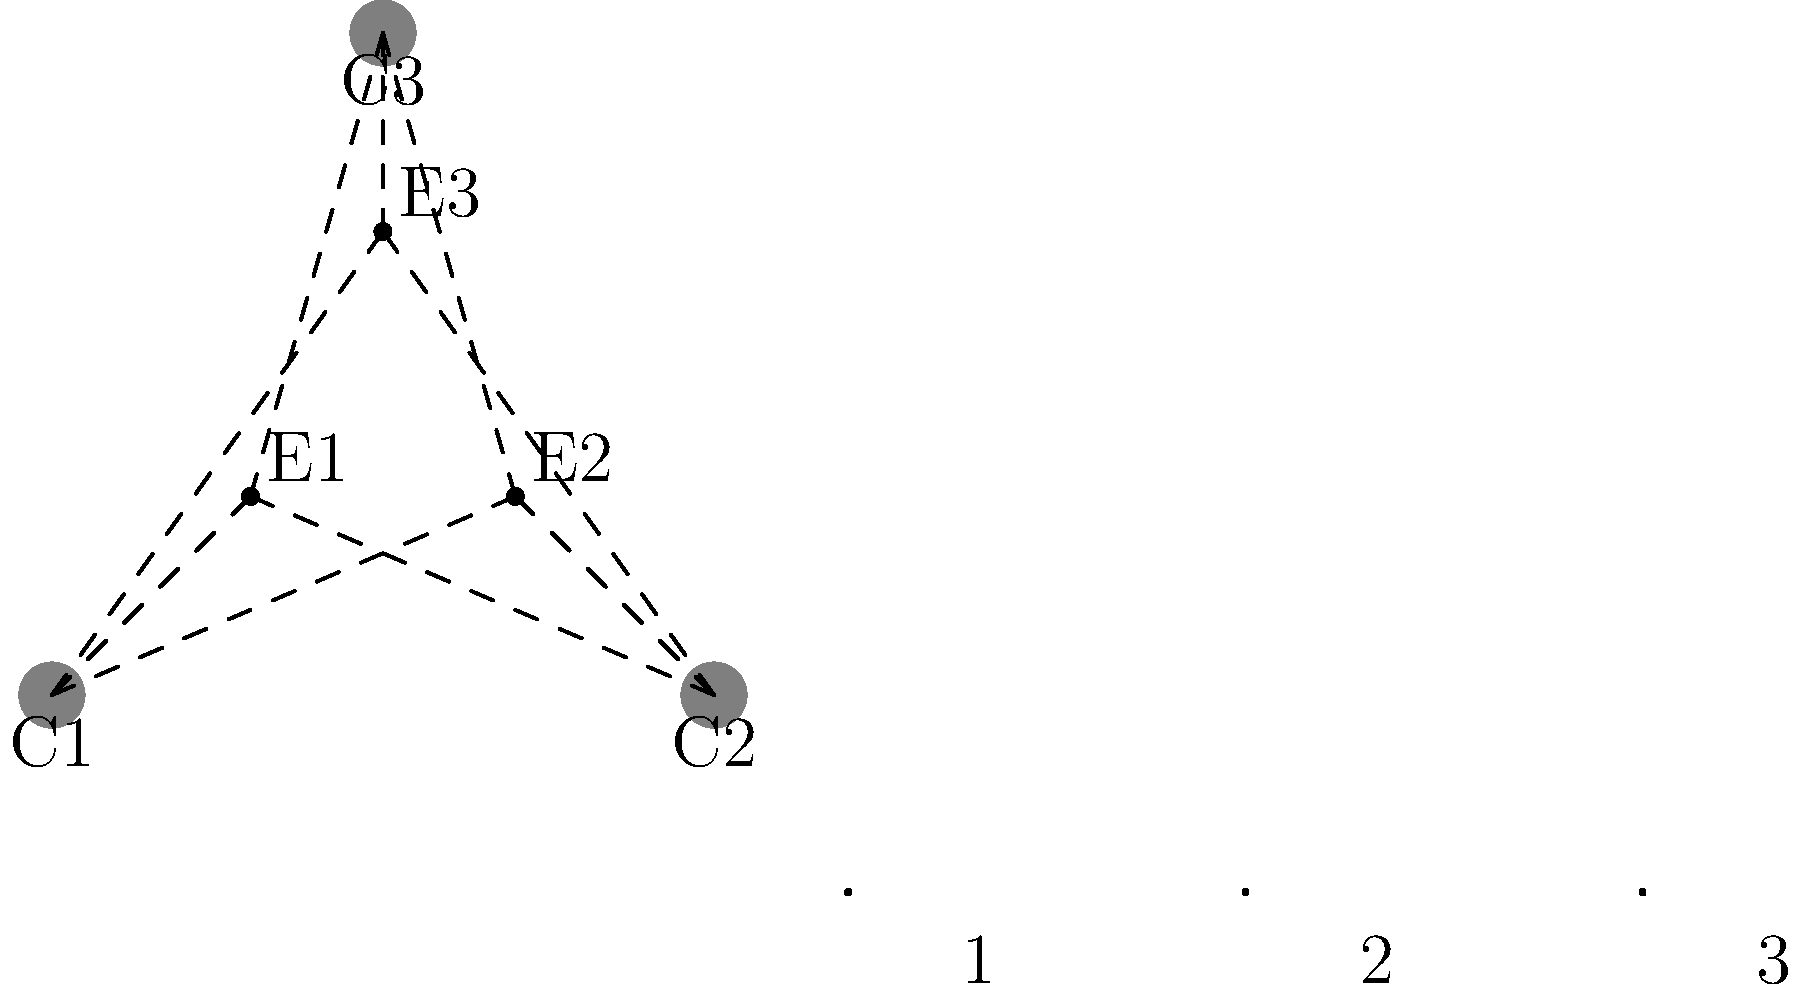In a comedic scene with three characters (E1, E2, E3) and three camera angles (C1, C2, C3), you need to create a storyboard sequence. Which camera angle would be most effective for the third frame to capture a sudden unexpected reaction from character E2? To determine the most effective camera angle for the third frame, let's analyze the scene and camera positions:

1. We have three characters (E1, E2, E3) positioned in a triangle formation.
2. There are three camera angles (C1, C2, C3) available.
3. The goal is to capture a sudden unexpected reaction from character E2.

Let's consider each camera angle:

1. C1 (bottom left):
   - Provides a side view of E2
   - May not fully capture facial expressions
   - Could create a sense of distance

2. C2 (bottom right):
   - Offers a direct view of E2
   - Ideal for capturing facial expressions and reactions
   - Creates an intimate connection with the audience

3. C3 (top center):
   - Provides an overhead view
   - May not clearly show facial expressions
   - Could be used for establishing shots or group dynamics

For a sudden unexpected reaction from E2:
- We want to clearly see the character's face and body language
- The audience should feel connected to the character's emotion
- The shot should emphasize the comedic timing of the reaction

Given these factors, camera angle C2 would be the most effective for the third frame. It provides a direct view of E2, allowing the audience to see the full extent of the unexpected reaction, which is crucial for comedic timing and impact.
Answer: C2 